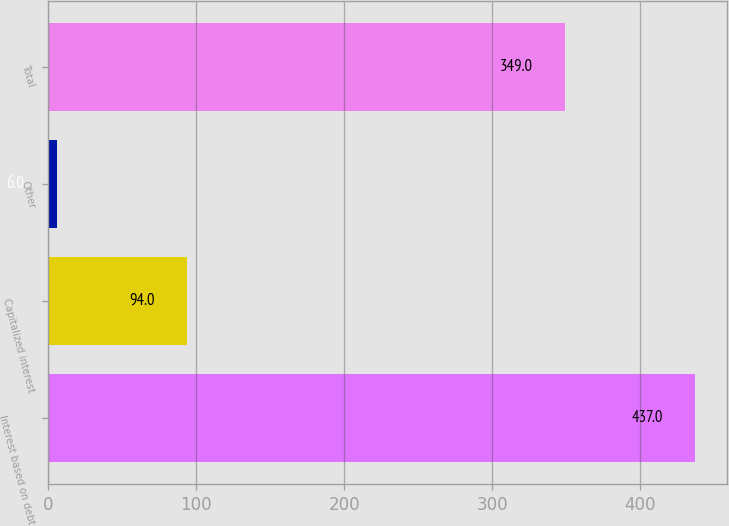Convert chart. <chart><loc_0><loc_0><loc_500><loc_500><bar_chart><fcel>Interest based on debt<fcel>Capitalized interest<fcel>Other<fcel>Total<nl><fcel>437<fcel>94<fcel>6<fcel>349<nl></chart> 